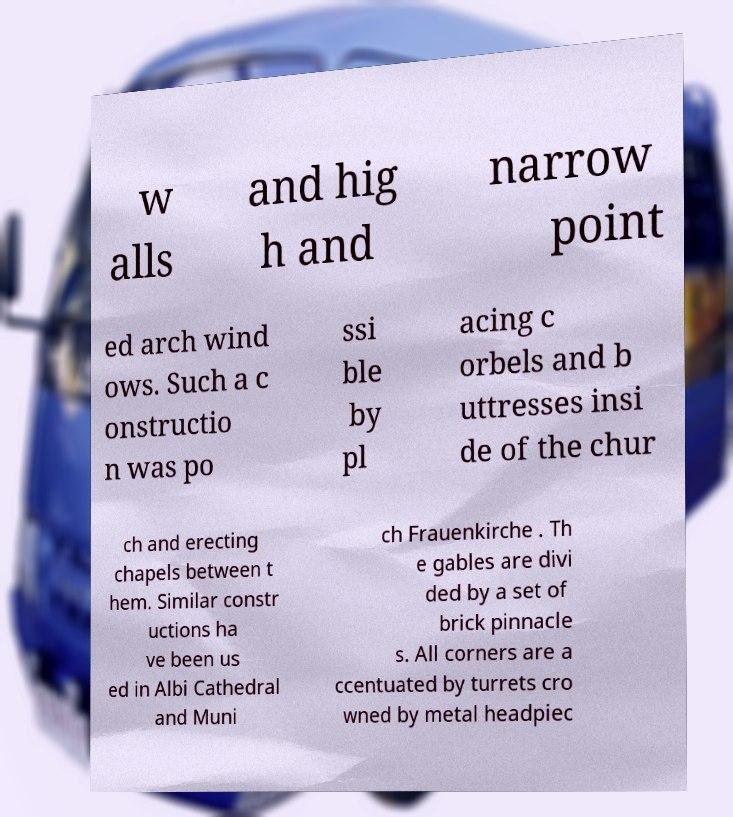Please read and relay the text visible in this image. What does it say? w alls and hig h and narrow point ed arch wind ows. Such a c onstructio n was po ssi ble by pl acing c orbels and b uttresses insi de of the chur ch and erecting chapels between t hem. Similar constr uctions ha ve been us ed in Albi Cathedral and Muni ch Frauenkirche . Th e gables are divi ded by a set of brick pinnacle s. All corners are a ccentuated by turrets cro wned by metal headpiec 